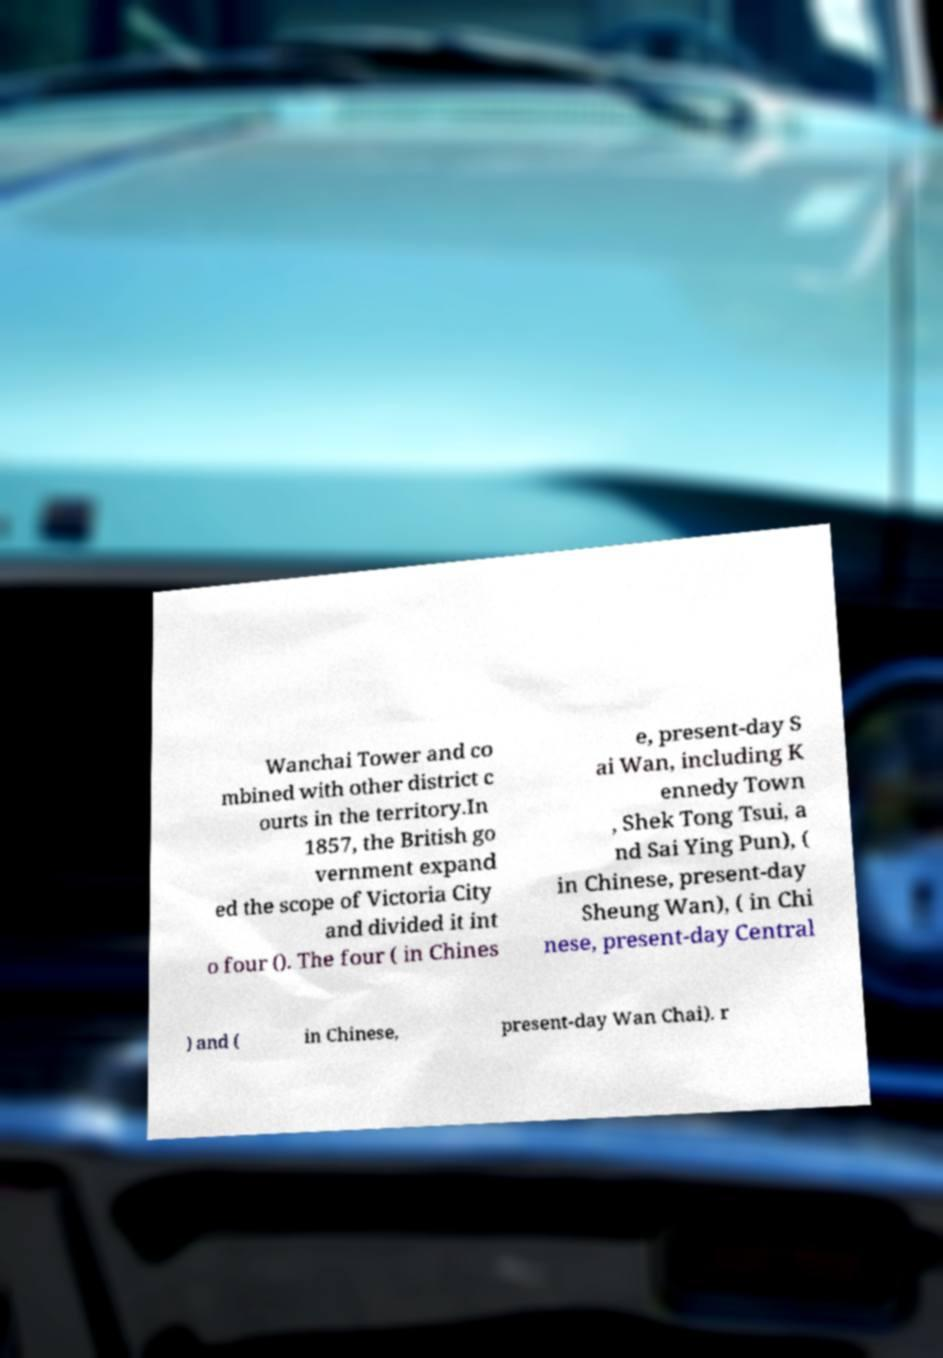For documentation purposes, I need the text within this image transcribed. Could you provide that? Wanchai Tower and co mbined with other district c ourts in the territory.In 1857, the British go vernment expand ed the scope of Victoria City and divided it int o four (). The four ( in Chines e, present-day S ai Wan, including K ennedy Town , Shek Tong Tsui, a nd Sai Ying Pun), ( in Chinese, present-day Sheung Wan), ( in Chi nese, present-day Central ) and ( in Chinese, present-day Wan Chai). r 